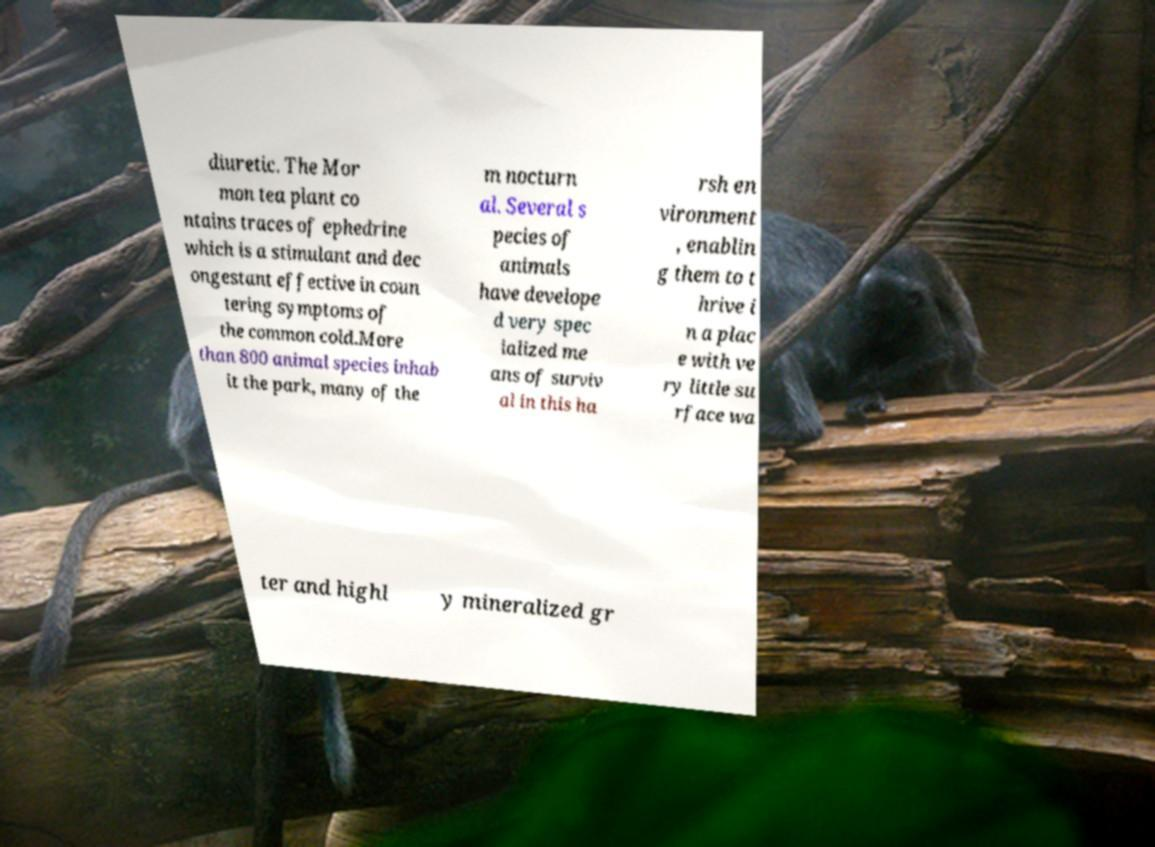Could you extract and type out the text from this image? diuretic. The Mor mon tea plant co ntains traces of ephedrine which is a stimulant and dec ongestant effective in coun tering symptoms of the common cold.More than 800 animal species inhab it the park, many of the m nocturn al. Several s pecies of animals have develope d very spec ialized me ans of surviv al in this ha rsh en vironment , enablin g them to t hrive i n a plac e with ve ry little su rface wa ter and highl y mineralized gr 